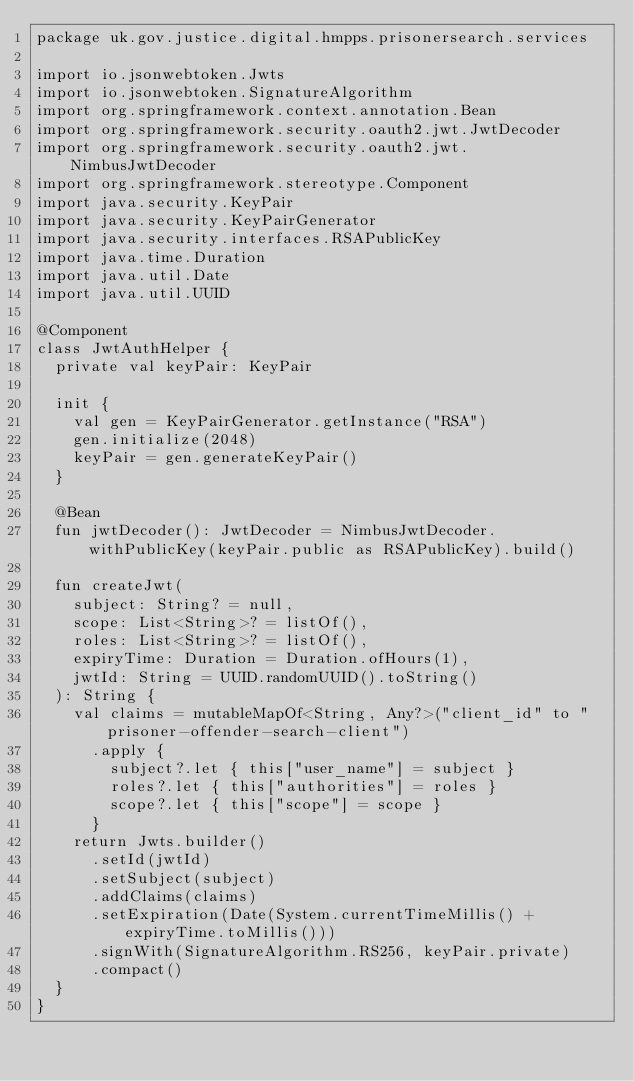Convert code to text. <code><loc_0><loc_0><loc_500><loc_500><_Kotlin_>package uk.gov.justice.digital.hmpps.prisonersearch.services

import io.jsonwebtoken.Jwts
import io.jsonwebtoken.SignatureAlgorithm
import org.springframework.context.annotation.Bean
import org.springframework.security.oauth2.jwt.JwtDecoder
import org.springframework.security.oauth2.jwt.NimbusJwtDecoder
import org.springframework.stereotype.Component
import java.security.KeyPair
import java.security.KeyPairGenerator
import java.security.interfaces.RSAPublicKey
import java.time.Duration
import java.util.Date
import java.util.UUID

@Component
class JwtAuthHelper {
  private val keyPair: KeyPair

  init {
    val gen = KeyPairGenerator.getInstance("RSA")
    gen.initialize(2048)
    keyPair = gen.generateKeyPair()
  }

  @Bean
  fun jwtDecoder(): JwtDecoder = NimbusJwtDecoder.withPublicKey(keyPair.public as RSAPublicKey).build()

  fun createJwt(
    subject: String? = null,
    scope: List<String>? = listOf(),
    roles: List<String>? = listOf(),
    expiryTime: Duration = Duration.ofHours(1),
    jwtId: String = UUID.randomUUID().toString()
  ): String {
    val claims = mutableMapOf<String, Any?>("client_id" to "prisoner-offender-search-client")
      .apply {
        subject?.let { this["user_name"] = subject }
        roles?.let { this["authorities"] = roles }
        scope?.let { this["scope"] = scope }
      }
    return Jwts.builder()
      .setId(jwtId)
      .setSubject(subject)
      .addClaims(claims)
      .setExpiration(Date(System.currentTimeMillis() + expiryTime.toMillis()))
      .signWith(SignatureAlgorithm.RS256, keyPair.private)
      .compact()
  }
}
</code> 